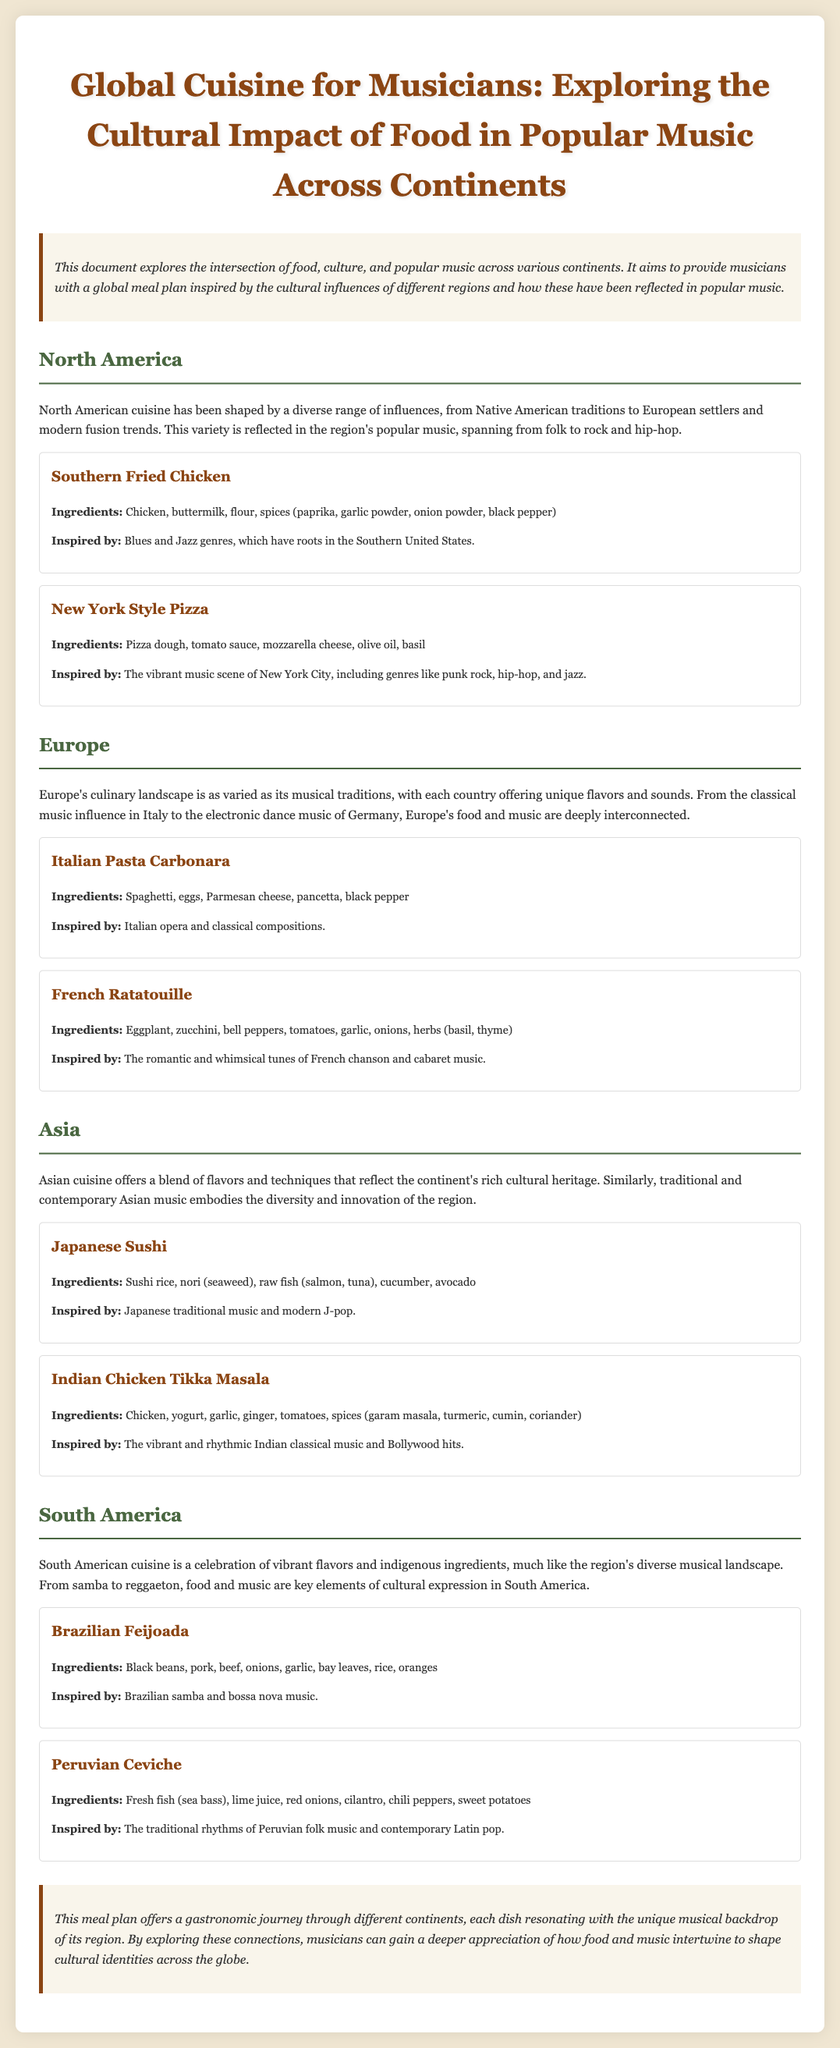what is the title of the document? The title of the document is prominently displayed at the top of the document.
Answer: Global Cuisine for Musicians: Exploring the Cultural Impact of Food in Popular Music Across Continents how many continents are covered in the meal plan? The document discusses the meal plan across four different continents.
Answer: Four what dish is inspired by Blues and Jazz genres? The document specifies which dish is linked to specific music genres.
Answer: Southern Fried Chicken which Asian dish includes avocado as an ingredient? The document lists ingredients for various dishes, indicating which dishes contain specific items.
Answer: Japanese Sushi what cuisine is associated with the major city of New York? The document connects certain dishes with cultural influences, including city references.
Answer: New York Style Pizza name one ingredient in the French Ratatouille. The dish description includes a list of ingredients; one must be selected.
Answer: Eggplant which South American dish includes limes? The document specifically mentions ingredients for dishes from South America.
Answer: Peruvian Ceviche what musical genre influences the Italian Pasta Carbonara? The document explicitly states the relationship between cuisine and musical genres for specific dishes.
Answer: Italian opera 